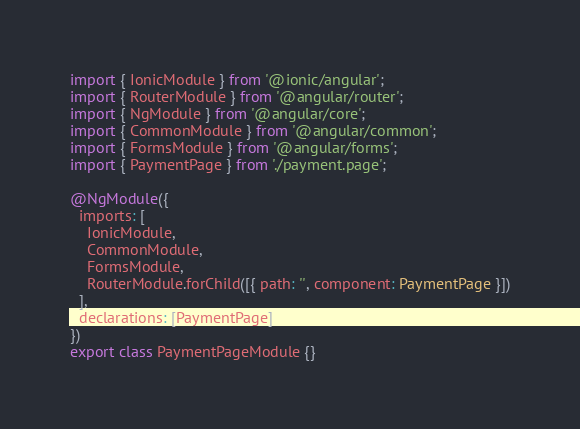<code> <loc_0><loc_0><loc_500><loc_500><_TypeScript_>import { IonicModule } from '@ionic/angular';
import { RouterModule } from '@angular/router';
import { NgModule } from '@angular/core';
import { CommonModule } from '@angular/common';
import { FormsModule } from '@angular/forms';
import { PaymentPage } from './payment.page';

@NgModule({
  imports: [
    IonicModule,
    CommonModule,
    FormsModule,
    RouterModule.forChild([{ path: '', component: PaymentPage }])
  ],
  declarations: [PaymentPage]
})
export class PaymentPageModule {}
</code> 